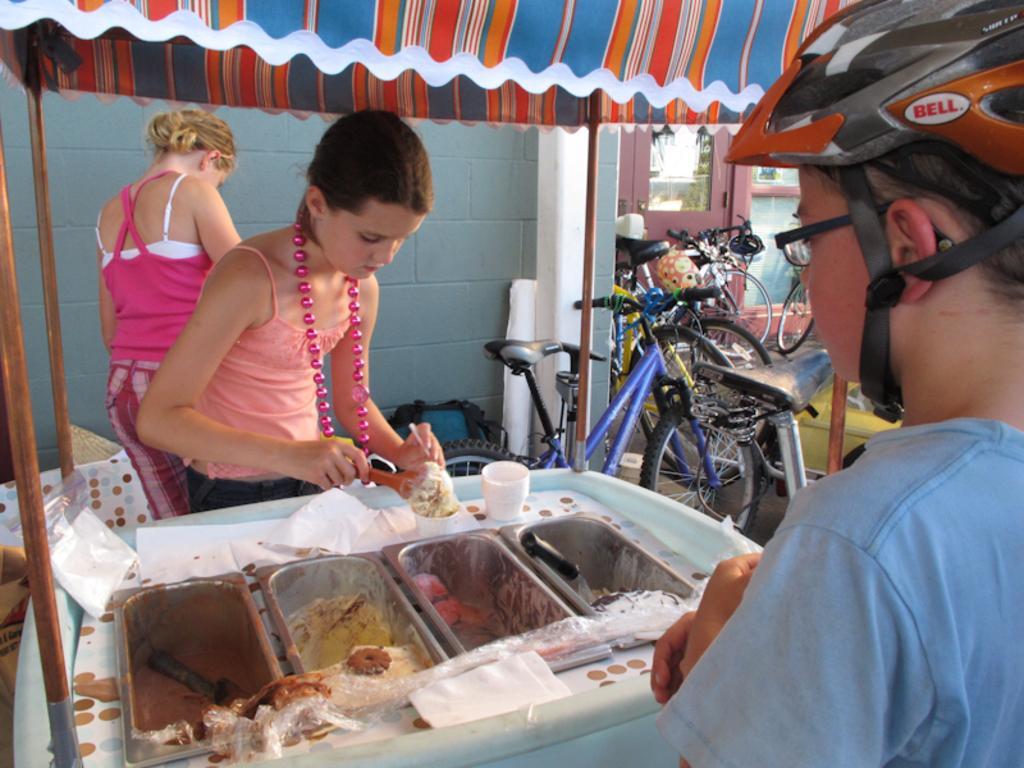Can you describe this image briefly? In this image I can see three people with different color dresses and one person with the helmet. In-front of these people I can see the utensils with ice-creams under the tent. To the right I can see the bicycles, door and the wall. 